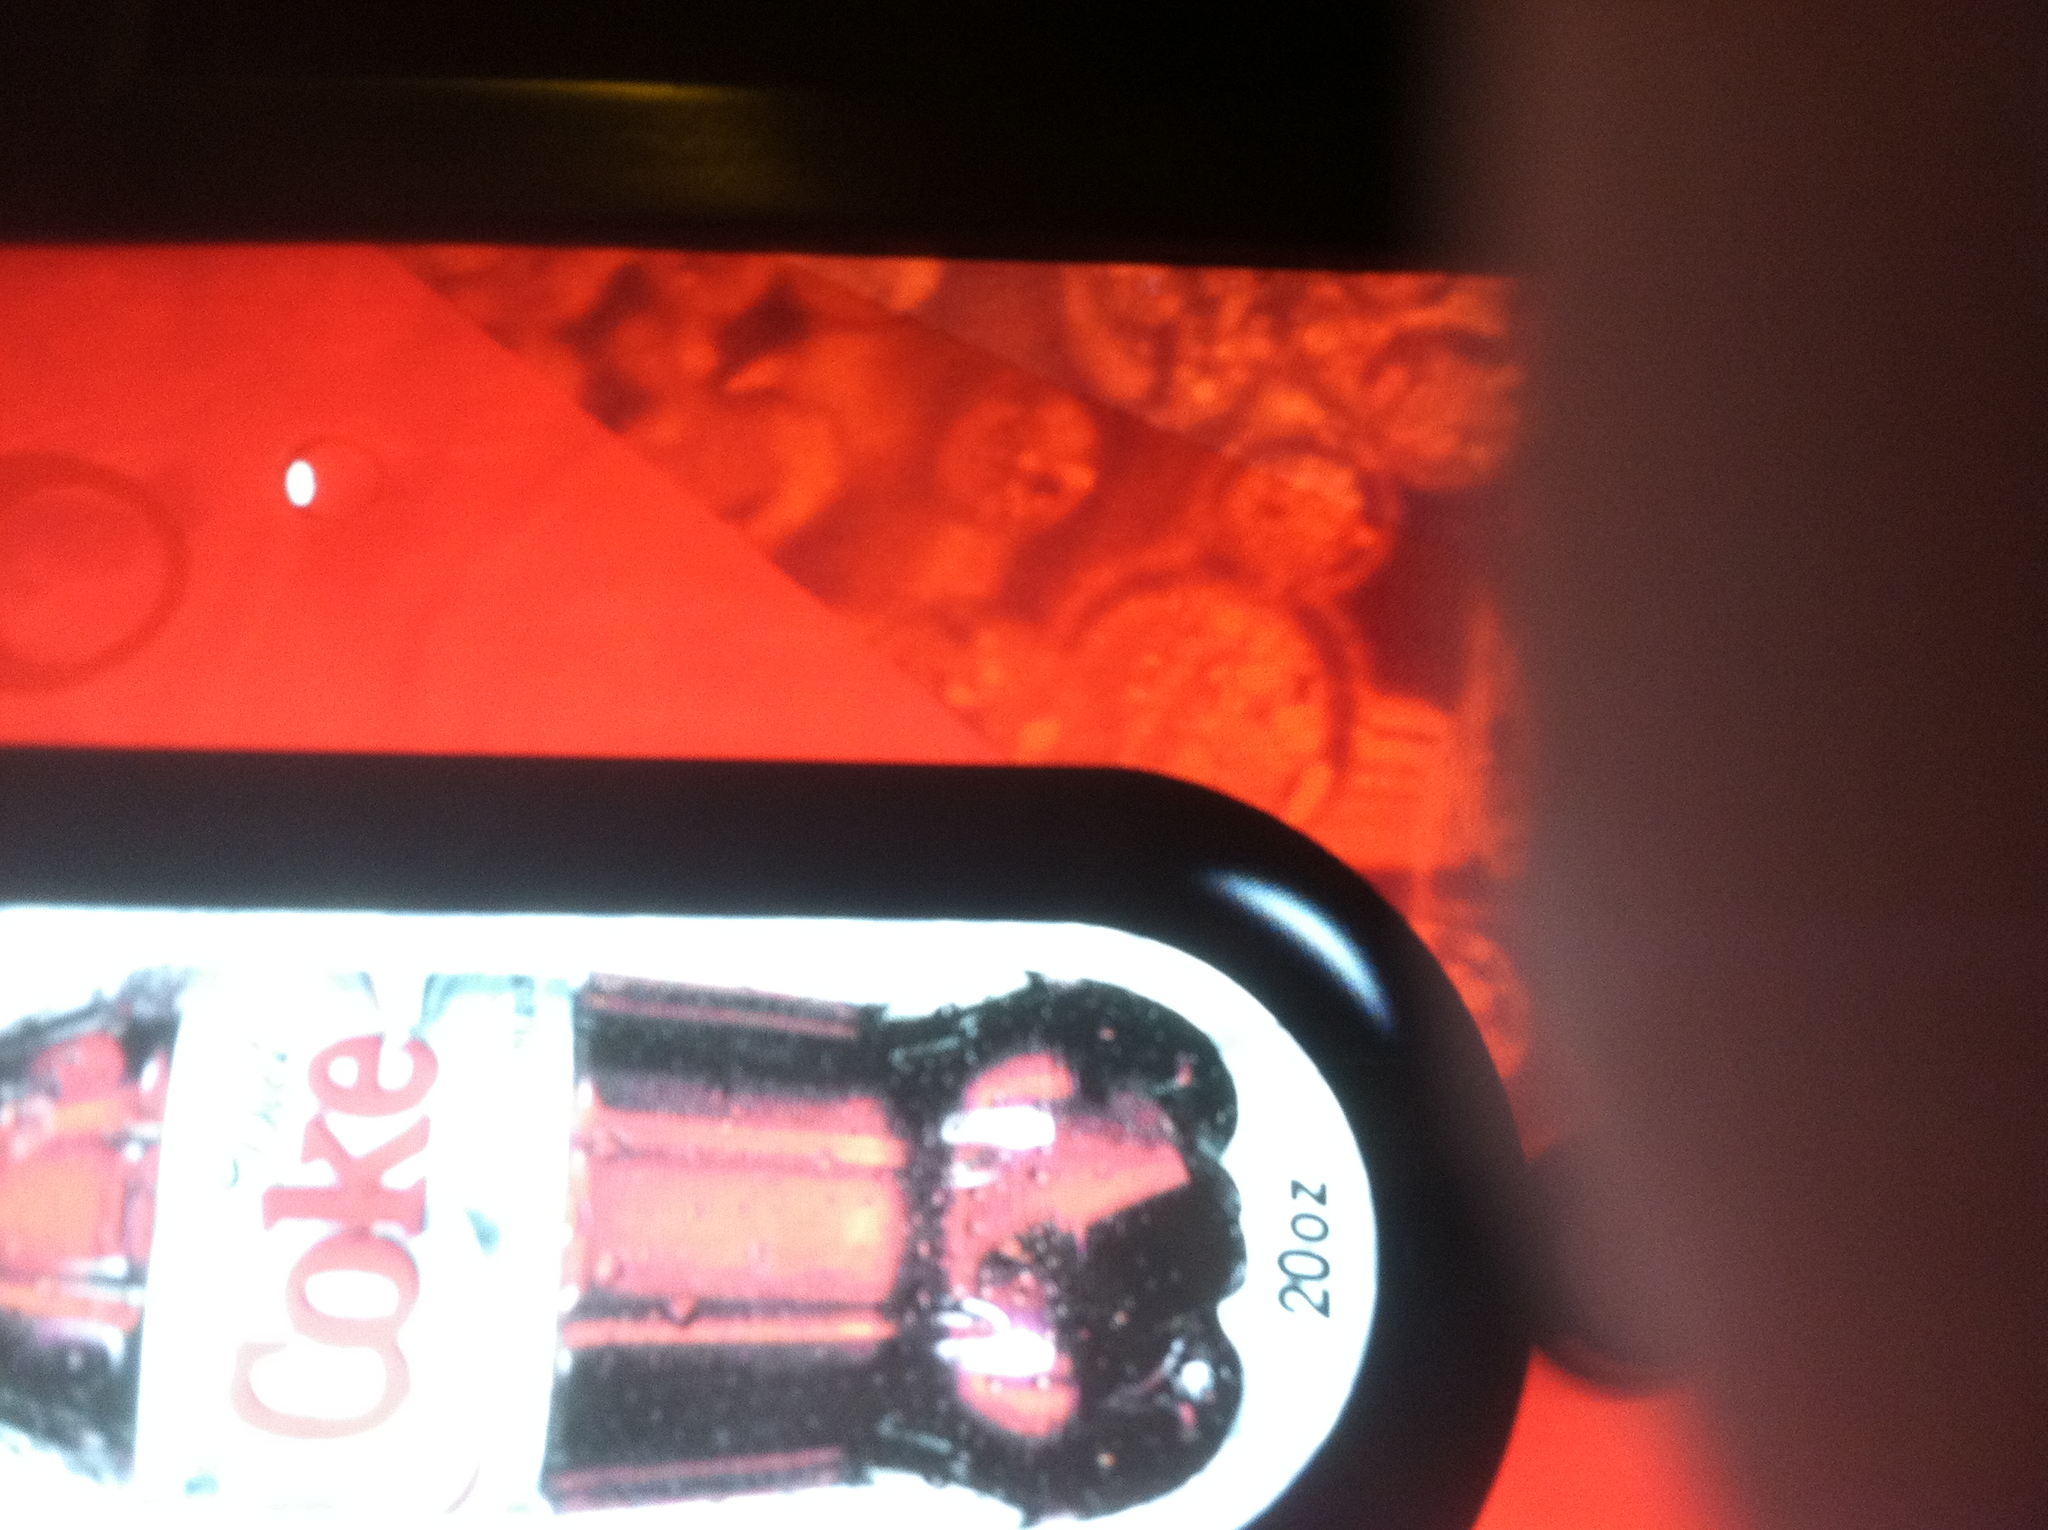Can you describe the color scheme and design used for this Coca-Cola product? The color scheme prominently features distinctive red and white colors, which are characteristic of Coca-Cola branding. The background includes abstract patterns in shades of red, creating a dynamic and visually appealing design. The Diet Coke itself is identified by its silver and red label, reflecting a sleek and modern look. Is there any indication of the bottle size? Yes, the label clearly indicates that the bottle size is 20 oz, which is a typical size for a single-serving bottle of Diet Coke. 